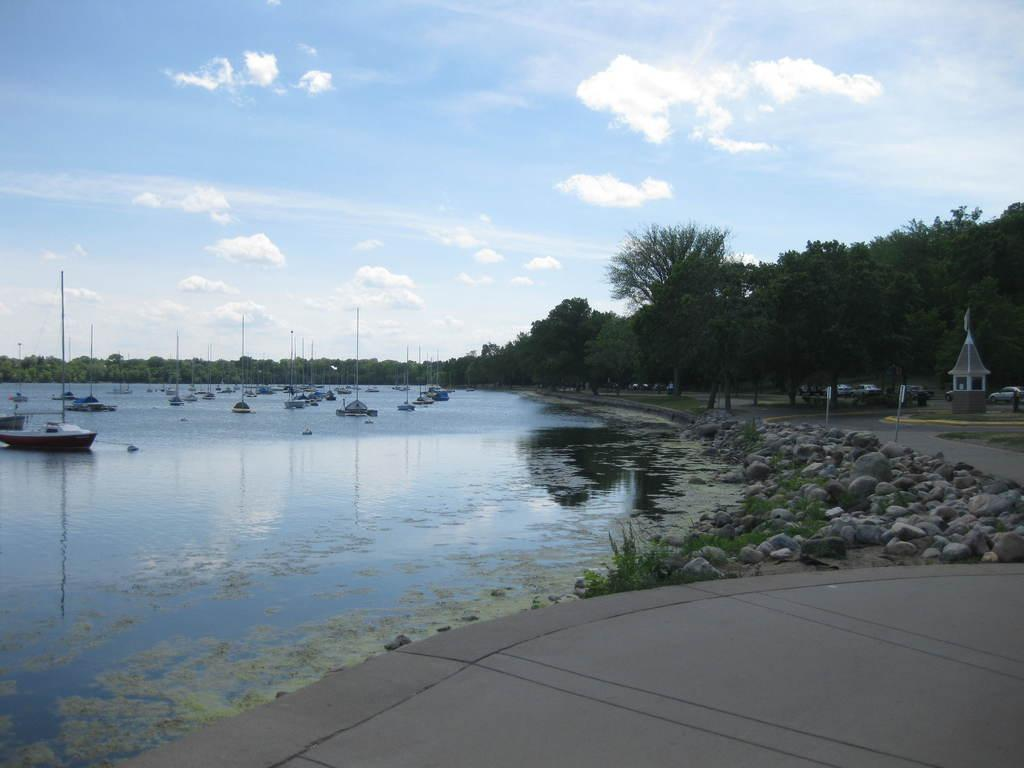What type of objects can be seen in the image? There are stones and boats in the image. What is the water in the image being used for? The water is being used by the boats. What can be seen in the background of the image? Trees with green color can be seen in the background of the image. What is the color of the sky in the image? The sky is visible in the image with blue and white colors. How does the stove function in the image? There is no stove present in the image. What type of zipper can be seen on the trees in the image? There are no zippers on the trees in the image; they are natural trees with green leaves. 